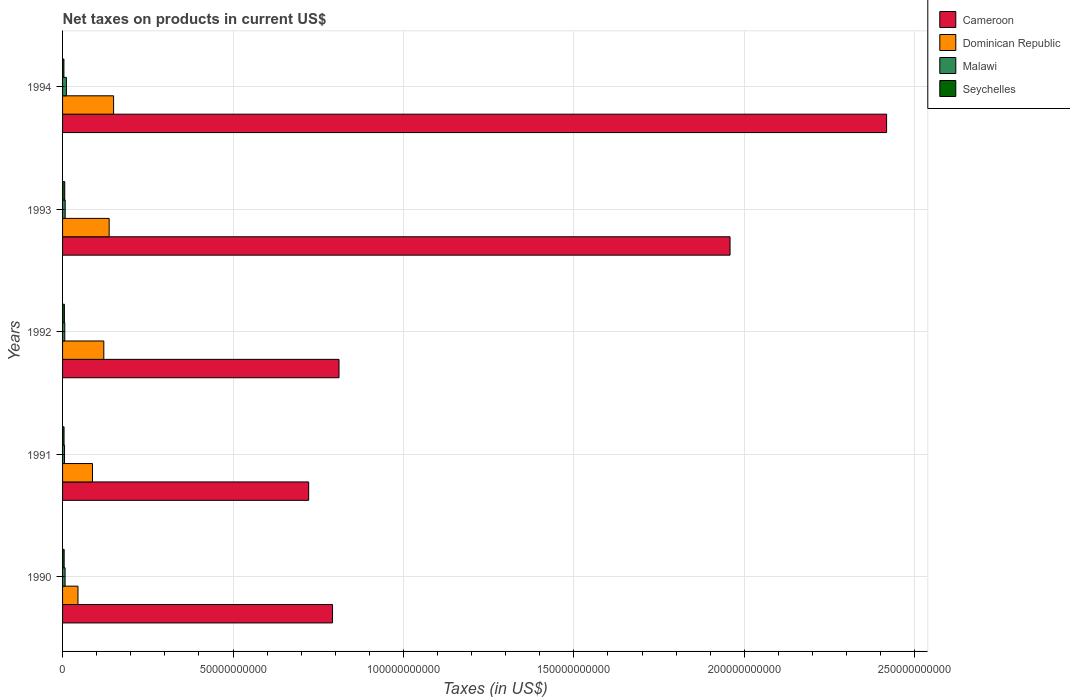How many groups of bars are there?
Offer a very short reply. 5. Are the number of bars per tick equal to the number of legend labels?
Your answer should be very brief. Yes. How many bars are there on the 2nd tick from the top?
Your answer should be compact. 4. How many bars are there on the 1st tick from the bottom?
Make the answer very short. 4. What is the label of the 3rd group of bars from the top?
Offer a very short reply. 1992. What is the net taxes on products in Dominican Republic in 1990?
Provide a short and direct response. 4.52e+09. Across all years, what is the maximum net taxes on products in Malawi?
Provide a succinct answer. 1.13e+09. Across all years, what is the minimum net taxes on products in Seychelles?
Your response must be concise. 3.99e+08. In which year was the net taxes on products in Dominican Republic maximum?
Make the answer very short. 1994. In which year was the net taxes on products in Malawi minimum?
Offer a very short reply. 1991. What is the total net taxes on products in Seychelles in the graph?
Offer a very short reply. 2.48e+09. What is the difference between the net taxes on products in Cameroon in 1990 and that in 1993?
Your answer should be very brief. -1.17e+11. What is the difference between the net taxes on products in Dominican Republic in 1994 and the net taxes on products in Cameroon in 1991?
Your answer should be very brief. -5.72e+1. What is the average net taxes on products in Cameroon per year?
Your answer should be compact. 1.34e+11. In the year 1992, what is the difference between the net taxes on products in Malawi and net taxes on products in Cameroon?
Keep it short and to the point. -8.05e+1. What is the ratio of the net taxes on products in Malawi in 1990 to that in 1992?
Provide a succinct answer. 1.15. Is the net taxes on products in Cameroon in 1990 less than that in 1993?
Keep it short and to the point. Yes. What is the difference between the highest and the second highest net taxes on products in Seychelles?
Provide a succinct answer. 1.05e+08. What is the difference between the highest and the lowest net taxes on products in Malawi?
Provide a short and direct response. 5.51e+08. Is the sum of the net taxes on products in Cameroon in 1990 and 1992 greater than the maximum net taxes on products in Seychelles across all years?
Offer a terse response. Yes. What does the 1st bar from the top in 1994 represents?
Make the answer very short. Seychelles. What does the 2nd bar from the bottom in 1990 represents?
Keep it short and to the point. Dominican Republic. How many bars are there?
Give a very brief answer. 20. Are all the bars in the graph horizontal?
Your answer should be very brief. Yes. How many years are there in the graph?
Provide a succinct answer. 5. How many legend labels are there?
Your answer should be compact. 4. What is the title of the graph?
Keep it short and to the point. Net taxes on products in current US$. Does "Fragile and conflict affected situations" appear as one of the legend labels in the graph?
Provide a short and direct response. No. What is the label or title of the X-axis?
Your response must be concise. Taxes (in US$). What is the label or title of the Y-axis?
Ensure brevity in your answer.  Years. What is the Taxes (in US$) in Cameroon in 1990?
Keep it short and to the point. 7.92e+1. What is the Taxes (in US$) of Dominican Republic in 1990?
Your response must be concise. 4.52e+09. What is the Taxes (in US$) of Malawi in 1990?
Your answer should be very brief. 7.43e+08. What is the Taxes (in US$) in Seychelles in 1990?
Give a very brief answer. 4.66e+08. What is the Taxes (in US$) in Cameroon in 1991?
Make the answer very short. 7.22e+1. What is the Taxes (in US$) in Dominican Republic in 1991?
Offer a terse response. 8.78e+09. What is the Taxes (in US$) in Malawi in 1991?
Provide a short and direct response. 5.76e+08. What is the Taxes (in US$) in Seychelles in 1991?
Provide a short and direct response. 4.37e+08. What is the Taxes (in US$) of Cameroon in 1992?
Make the answer very short. 8.11e+1. What is the Taxes (in US$) in Dominican Republic in 1992?
Provide a short and direct response. 1.21e+1. What is the Taxes (in US$) of Malawi in 1992?
Your answer should be very brief. 6.49e+08. What is the Taxes (in US$) of Seychelles in 1992?
Provide a succinct answer. 5.37e+08. What is the Taxes (in US$) of Cameroon in 1993?
Give a very brief answer. 1.96e+11. What is the Taxes (in US$) in Dominican Republic in 1993?
Ensure brevity in your answer.  1.37e+1. What is the Taxes (in US$) in Malawi in 1993?
Provide a short and direct response. 7.68e+08. What is the Taxes (in US$) of Seychelles in 1993?
Offer a very short reply. 6.43e+08. What is the Taxes (in US$) of Cameroon in 1994?
Ensure brevity in your answer.  2.42e+11. What is the Taxes (in US$) of Dominican Republic in 1994?
Provide a succinct answer. 1.50e+1. What is the Taxes (in US$) of Malawi in 1994?
Your answer should be very brief. 1.13e+09. What is the Taxes (in US$) of Seychelles in 1994?
Your response must be concise. 3.99e+08. Across all years, what is the maximum Taxes (in US$) of Cameroon?
Offer a very short reply. 2.42e+11. Across all years, what is the maximum Taxes (in US$) in Dominican Republic?
Your answer should be very brief. 1.50e+1. Across all years, what is the maximum Taxes (in US$) in Malawi?
Ensure brevity in your answer.  1.13e+09. Across all years, what is the maximum Taxes (in US$) of Seychelles?
Offer a very short reply. 6.43e+08. Across all years, what is the minimum Taxes (in US$) in Cameroon?
Make the answer very short. 7.22e+1. Across all years, what is the minimum Taxes (in US$) in Dominican Republic?
Give a very brief answer. 4.52e+09. Across all years, what is the minimum Taxes (in US$) of Malawi?
Offer a terse response. 5.76e+08. Across all years, what is the minimum Taxes (in US$) of Seychelles?
Ensure brevity in your answer.  3.99e+08. What is the total Taxes (in US$) in Cameroon in the graph?
Give a very brief answer. 6.70e+11. What is the total Taxes (in US$) in Dominican Republic in the graph?
Give a very brief answer. 5.40e+1. What is the total Taxes (in US$) in Malawi in the graph?
Keep it short and to the point. 3.86e+09. What is the total Taxes (in US$) in Seychelles in the graph?
Provide a short and direct response. 2.48e+09. What is the difference between the Taxes (in US$) of Cameroon in 1990 and that in 1991?
Provide a succinct answer. 7.00e+09. What is the difference between the Taxes (in US$) in Dominican Republic in 1990 and that in 1991?
Your answer should be very brief. -4.26e+09. What is the difference between the Taxes (in US$) in Malawi in 1990 and that in 1991?
Keep it short and to the point. 1.68e+08. What is the difference between the Taxes (in US$) in Seychelles in 1990 and that in 1991?
Give a very brief answer. 2.95e+07. What is the difference between the Taxes (in US$) in Cameroon in 1990 and that in 1992?
Your answer should be very brief. -1.90e+09. What is the difference between the Taxes (in US$) of Dominican Republic in 1990 and that in 1992?
Keep it short and to the point. -7.58e+09. What is the difference between the Taxes (in US$) of Malawi in 1990 and that in 1992?
Your response must be concise. 9.45e+07. What is the difference between the Taxes (in US$) in Seychelles in 1990 and that in 1992?
Offer a very short reply. -7.12e+07. What is the difference between the Taxes (in US$) in Cameroon in 1990 and that in 1993?
Give a very brief answer. -1.17e+11. What is the difference between the Taxes (in US$) in Dominican Republic in 1990 and that in 1993?
Provide a short and direct response. -9.15e+09. What is the difference between the Taxes (in US$) of Malawi in 1990 and that in 1993?
Make the answer very short. -2.50e+07. What is the difference between the Taxes (in US$) in Seychelles in 1990 and that in 1993?
Provide a short and direct response. -1.76e+08. What is the difference between the Taxes (in US$) in Cameroon in 1990 and that in 1994?
Offer a very short reply. -1.63e+11. What is the difference between the Taxes (in US$) of Dominican Republic in 1990 and that in 1994?
Ensure brevity in your answer.  -1.04e+1. What is the difference between the Taxes (in US$) of Malawi in 1990 and that in 1994?
Provide a succinct answer. -3.83e+08. What is the difference between the Taxes (in US$) of Seychelles in 1990 and that in 1994?
Keep it short and to the point. 6.71e+07. What is the difference between the Taxes (in US$) in Cameroon in 1991 and that in 1992?
Ensure brevity in your answer.  -8.90e+09. What is the difference between the Taxes (in US$) in Dominican Republic in 1991 and that in 1992?
Provide a short and direct response. -3.32e+09. What is the difference between the Taxes (in US$) in Malawi in 1991 and that in 1992?
Provide a succinct answer. -7.32e+07. What is the difference between the Taxes (in US$) of Seychelles in 1991 and that in 1992?
Your answer should be very brief. -1.01e+08. What is the difference between the Taxes (in US$) of Cameroon in 1991 and that in 1993?
Give a very brief answer. -1.24e+11. What is the difference between the Taxes (in US$) of Dominican Republic in 1991 and that in 1993?
Provide a short and direct response. -4.89e+09. What is the difference between the Taxes (in US$) of Malawi in 1991 and that in 1993?
Your answer should be very brief. -1.93e+08. What is the difference between the Taxes (in US$) in Seychelles in 1991 and that in 1993?
Provide a succinct answer. -2.06e+08. What is the difference between the Taxes (in US$) in Cameroon in 1991 and that in 1994?
Ensure brevity in your answer.  -1.70e+11. What is the difference between the Taxes (in US$) of Dominican Republic in 1991 and that in 1994?
Provide a short and direct response. -6.19e+09. What is the difference between the Taxes (in US$) in Malawi in 1991 and that in 1994?
Your response must be concise. -5.51e+08. What is the difference between the Taxes (in US$) in Seychelles in 1991 and that in 1994?
Ensure brevity in your answer.  3.76e+07. What is the difference between the Taxes (in US$) of Cameroon in 1992 and that in 1993?
Provide a succinct answer. -1.15e+11. What is the difference between the Taxes (in US$) in Dominican Republic in 1992 and that in 1993?
Keep it short and to the point. -1.57e+09. What is the difference between the Taxes (in US$) in Malawi in 1992 and that in 1993?
Provide a short and direct response. -1.20e+08. What is the difference between the Taxes (in US$) of Seychelles in 1992 and that in 1993?
Your answer should be very brief. -1.05e+08. What is the difference between the Taxes (in US$) of Cameroon in 1992 and that in 1994?
Keep it short and to the point. -1.61e+11. What is the difference between the Taxes (in US$) in Dominican Republic in 1992 and that in 1994?
Offer a terse response. -2.87e+09. What is the difference between the Taxes (in US$) in Malawi in 1992 and that in 1994?
Offer a terse response. -4.77e+08. What is the difference between the Taxes (in US$) of Seychelles in 1992 and that in 1994?
Make the answer very short. 1.38e+08. What is the difference between the Taxes (in US$) of Cameroon in 1993 and that in 1994?
Your response must be concise. -4.59e+1. What is the difference between the Taxes (in US$) of Dominican Republic in 1993 and that in 1994?
Ensure brevity in your answer.  -1.30e+09. What is the difference between the Taxes (in US$) in Malawi in 1993 and that in 1994?
Make the answer very short. -3.58e+08. What is the difference between the Taxes (in US$) of Seychelles in 1993 and that in 1994?
Make the answer very short. 2.44e+08. What is the difference between the Taxes (in US$) of Cameroon in 1990 and the Taxes (in US$) of Dominican Republic in 1991?
Provide a succinct answer. 7.04e+1. What is the difference between the Taxes (in US$) in Cameroon in 1990 and the Taxes (in US$) in Malawi in 1991?
Give a very brief answer. 7.86e+1. What is the difference between the Taxes (in US$) in Cameroon in 1990 and the Taxes (in US$) in Seychelles in 1991?
Provide a short and direct response. 7.88e+1. What is the difference between the Taxes (in US$) in Dominican Republic in 1990 and the Taxes (in US$) in Malawi in 1991?
Ensure brevity in your answer.  3.95e+09. What is the difference between the Taxes (in US$) of Dominican Republic in 1990 and the Taxes (in US$) of Seychelles in 1991?
Offer a very short reply. 4.09e+09. What is the difference between the Taxes (in US$) of Malawi in 1990 and the Taxes (in US$) of Seychelles in 1991?
Your answer should be very brief. 3.07e+08. What is the difference between the Taxes (in US$) in Cameroon in 1990 and the Taxes (in US$) in Dominican Republic in 1992?
Provide a succinct answer. 6.71e+1. What is the difference between the Taxes (in US$) of Cameroon in 1990 and the Taxes (in US$) of Malawi in 1992?
Make the answer very short. 7.86e+1. What is the difference between the Taxes (in US$) of Cameroon in 1990 and the Taxes (in US$) of Seychelles in 1992?
Keep it short and to the point. 7.87e+1. What is the difference between the Taxes (in US$) of Dominican Republic in 1990 and the Taxes (in US$) of Malawi in 1992?
Your answer should be compact. 3.87e+09. What is the difference between the Taxes (in US$) in Dominican Republic in 1990 and the Taxes (in US$) in Seychelles in 1992?
Offer a terse response. 3.99e+09. What is the difference between the Taxes (in US$) in Malawi in 1990 and the Taxes (in US$) in Seychelles in 1992?
Your answer should be very brief. 2.06e+08. What is the difference between the Taxes (in US$) of Cameroon in 1990 and the Taxes (in US$) of Dominican Republic in 1993?
Your answer should be very brief. 6.55e+1. What is the difference between the Taxes (in US$) in Cameroon in 1990 and the Taxes (in US$) in Malawi in 1993?
Your response must be concise. 7.84e+1. What is the difference between the Taxes (in US$) of Cameroon in 1990 and the Taxes (in US$) of Seychelles in 1993?
Provide a succinct answer. 7.86e+1. What is the difference between the Taxes (in US$) of Dominican Republic in 1990 and the Taxes (in US$) of Malawi in 1993?
Your response must be concise. 3.75e+09. What is the difference between the Taxes (in US$) of Dominican Republic in 1990 and the Taxes (in US$) of Seychelles in 1993?
Your answer should be very brief. 3.88e+09. What is the difference between the Taxes (in US$) in Malawi in 1990 and the Taxes (in US$) in Seychelles in 1993?
Provide a succinct answer. 1.01e+08. What is the difference between the Taxes (in US$) in Cameroon in 1990 and the Taxes (in US$) in Dominican Republic in 1994?
Make the answer very short. 6.42e+1. What is the difference between the Taxes (in US$) of Cameroon in 1990 and the Taxes (in US$) of Malawi in 1994?
Your answer should be compact. 7.81e+1. What is the difference between the Taxes (in US$) of Cameroon in 1990 and the Taxes (in US$) of Seychelles in 1994?
Provide a succinct answer. 7.88e+1. What is the difference between the Taxes (in US$) in Dominican Republic in 1990 and the Taxes (in US$) in Malawi in 1994?
Keep it short and to the point. 3.40e+09. What is the difference between the Taxes (in US$) of Dominican Republic in 1990 and the Taxes (in US$) of Seychelles in 1994?
Offer a very short reply. 4.12e+09. What is the difference between the Taxes (in US$) in Malawi in 1990 and the Taxes (in US$) in Seychelles in 1994?
Your response must be concise. 3.44e+08. What is the difference between the Taxes (in US$) of Cameroon in 1991 and the Taxes (in US$) of Dominican Republic in 1992?
Your answer should be compact. 6.01e+1. What is the difference between the Taxes (in US$) of Cameroon in 1991 and the Taxes (in US$) of Malawi in 1992?
Provide a succinct answer. 7.16e+1. What is the difference between the Taxes (in US$) of Cameroon in 1991 and the Taxes (in US$) of Seychelles in 1992?
Offer a terse response. 7.17e+1. What is the difference between the Taxes (in US$) in Dominican Republic in 1991 and the Taxes (in US$) in Malawi in 1992?
Make the answer very short. 8.13e+09. What is the difference between the Taxes (in US$) in Dominican Republic in 1991 and the Taxes (in US$) in Seychelles in 1992?
Keep it short and to the point. 8.24e+09. What is the difference between the Taxes (in US$) in Malawi in 1991 and the Taxes (in US$) in Seychelles in 1992?
Your answer should be very brief. 3.82e+07. What is the difference between the Taxes (in US$) in Cameroon in 1991 and the Taxes (in US$) in Dominican Republic in 1993?
Make the answer very short. 5.85e+1. What is the difference between the Taxes (in US$) of Cameroon in 1991 and the Taxes (in US$) of Malawi in 1993?
Your response must be concise. 7.14e+1. What is the difference between the Taxes (in US$) of Cameroon in 1991 and the Taxes (in US$) of Seychelles in 1993?
Make the answer very short. 7.16e+1. What is the difference between the Taxes (in US$) in Dominican Republic in 1991 and the Taxes (in US$) in Malawi in 1993?
Your answer should be very brief. 8.01e+09. What is the difference between the Taxes (in US$) in Dominican Republic in 1991 and the Taxes (in US$) in Seychelles in 1993?
Provide a succinct answer. 8.14e+09. What is the difference between the Taxes (in US$) of Malawi in 1991 and the Taxes (in US$) of Seychelles in 1993?
Give a very brief answer. -6.71e+07. What is the difference between the Taxes (in US$) of Cameroon in 1991 and the Taxes (in US$) of Dominican Republic in 1994?
Your answer should be very brief. 5.72e+1. What is the difference between the Taxes (in US$) in Cameroon in 1991 and the Taxes (in US$) in Malawi in 1994?
Your answer should be very brief. 7.11e+1. What is the difference between the Taxes (in US$) in Cameroon in 1991 and the Taxes (in US$) in Seychelles in 1994?
Your answer should be very brief. 7.18e+1. What is the difference between the Taxes (in US$) of Dominican Republic in 1991 and the Taxes (in US$) of Malawi in 1994?
Provide a short and direct response. 7.66e+09. What is the difference between the Taxes (in US$) of Dominican Republic in 1991 and the Taxes (in US$) of Seychelles in 1994?
Make the answer very short. 8.38e+09. What is the difference between the Taxes (in US$) of Malawi in 1991 and the Taxes (in US$) of Seychelles in 1994?
Give a very brief answer. 1.76e+08. What is the difference between the Taxes (in US$) of Cameroon in 1992 and the Taxes (in US$) of Dominican Republic in 1993?
Provide a succinct answer. 6.74e+1. What is the difference between the Taxes (in US$) of Cameroon in 1992 and the Taxes (in US$) of Malawi in 1993?
Keep it short and to the point. 8.03e+1. What is the difference between the Taxes (in US$) in Cameroon in 1992 and the Taxes (in US$) in Seychelles in 1993?
Your answer should be very brief. 8.05e+1. What is the difference between the Taxes (in US$) in Dominican Republic in 1992 and the Taxes (in US$) in Malawi in 1993?
Your answer should be compact. 1.13e+1. What is the difference between the Taxes (in US$) in Dominican Republic in 1992 and the Taxes (in US$) in Seychelles in 1993?
Your answer should be very brief. 1.15e+1. What is the difference between the Taxes (in US$) in Malawi in 1992 and the Taxes (in US$) in Seychelles in 1993?
Your answer should be compact. 6.10e+06. What is the difference between the Taxes (in US$) of Cameroon in 1992 and the Taxes (in US$) of Dominican Republic in 1994?
Ensure brevity in your answer.  6.61e+1. What is the difference between the Taxes (in US$) in Cameroon in 1992 and the Taxes (in US$) in Malawi in 1994?
Offer a terse response. 8.00e+1. What is the difference between the Taxes (in US$) in Cameroon in 1992 and the Taxes (in US$) in Seychelles in 1994?
Your answer should be compact. 8.07e+1. What is the difference between the Taxes (in US$) in Dominican Republic in 1992 and the Taxes (in US$) in Malawi in 1994?
Offer a very short reply. 1.10e+1. What is the difference between the Taxes (in US$) in Dominican Republic in 1992 and the Taxes (in US$) in Seychelles in 1994?
Your answer should be compact. 1.17e+1. What is the difference between the Taxes (in US$) in Malawi in 1992 and the Taxes (in US$) in Seychelles in 1994?
Your response must be concise. 2.50e+08. What is the difference between the Taxes (in US$) of Cameroon in 1993 and the Taxes (in US$) of Dominican Republic in 1994?
Ensure brevity in your answer.  1.81e+11. What is the difference between the Taxes (in US$) of Cameroon in 1993 and the Taxes (in US$) of Malawi in 1994?
Offer a very short reply. 1.95e+11. What is the difference between the Taxes (in US$) of Cameroon in 1993 and the Taxes (in US$) of Seychelles in 1994?
Make the answer very short. 1.95e+11. What is the difference between the Taxes (in US$) of Dominican Republic in 1993 and the Taxes (in US$) of Malawi in 1994?
Your response must be concise. 1.25e+1. What is the difference between the Taxes (in US$) in Dominican Republic in 1993 and the Taxes (in US$) in Seychelles in 1994?
Provide a succinct answer. 1.33e+1. What is the difference between the Taxes (in US$) of Malawi in 1993 and the Taxes (in US$) of Seychelles in 1994?
Give a very brief answer. 3.69e+08. What is the average Taxes (in US$) in Cameroon per year?
Make the answer very short. 1.34e+11. What is the average Taxes (in US$) of Dominican Republic per year?
Offer a terse response. 1.08e+1. What is the average Taxes (in US$) in Malawi per year?
Your response must be concise. 7.72e+08. What is the average Taxes (in US$) in Seychelles per year?
Make the answer very short. 4.96e+08. In the year 1990, what is the difference between the Taxes (in US$) in Cameroon and Taxes (in US$) in Dominican Republic?
Make the answer very short. 7.47e+1. In the year 1990, what is the difference between the Taxes (in US$) of Cameroon and Taxes (in US$) of Malawi?
Provide a succinct answer. 7.85e+1. In the year 1990, what is the difference between the Taxes (in US$) in Cameroon and Taxes (in US$) in Seychelles?
Keep it short and to the point. 7.87e+1. In the year 1990, what is the difference between the Taxes (in US$) of Dominican Republic and Taxes (in US$) of Malawi?
Provide a succinct answer. 3.78e+09. In the year 1990, what is the difference between the Taxes (in US$) of Dominican Republic and Taxes (in US$) of Seychelles?
Offer a terse response. 4.06e+09. In the year 1990, what is the difference between the Taxes (in US$) of Malawi and Taxes (in US$) of Seychelles?
Your response must be concise. 2.77e+08. In the year 1991, what is the difference between the Taxes (in US$) of Cameroon and Taxes (in US$) of Dominican Republic?
Your answer should be very brief. 6.34e+1. In the year 1991, what is the difference between the Taxes (in US$) of Cameroon and Taxes (in US$) of Malawi?
Make the answer very short. 7.16e+1. In the year 1991, what is the difference between the Taxes (in US$) in Cameroon and Taxes (in US$) in Seychelles?
Ensure brevity in your answer.  7.18e+1. In the year 1991, what is the difference between the Taxes (in US$) in Dominican Republic and Taxes (in US$) in Malawi?
Ensure brevity in your answer.  8.21e+09. In the year 1991, what is the difference between the Taxes (in US$) in Dominican Republic and Taxes (in US$) in Seychelles?
Offer a very short reply. 8.35e+09. In the year 1991, what is the difference between the Taxes (in US$) of Malawi and Taxes (in US$) of Seychelles?
Your answer should be very brief. 1.39e+08. In the year 1992, what is the difference between the Taxes (in US$) in Cameroon and Taxes (in US$) in Dominican Republic?
Make the answer very short. 6.90e+1. In the year 1992, what is the difference between the Taxes (in US$) of Cameroon and Taxes (in US$) of Malawi?
Your response must be concise. 8.05e+1. In the year 1992, what is the difference between the Taxes (in US$) of Cameroon and Taxes (in US$) of Seychelles?
Your answer should be very brief. 8.06e+1. In the year 1992, what is the difference between the Taxes (in US$) in Dominican Republic and Taxes (in US$) in Malawi?
Ensure brevity in your answer.  1.15e+1. In the year 1992, what is the difference between the Taxes (in US$) in Dominican Republic and Taxes (in US$) in Seychelles?
Offer a terse response. 1.16e+1. In the year 1992, what is the difference between the Taxes (in US$) of Malawi and Taxes (in US$) of Seychelles?
Provide a succinct answer. 1.11e+08. In the year 1993, what is the difference between the Taxes (in US$) in Cameroon and Taxes (in US$) in Dominican Republic?
Keep it short and to the point. 1.82e+11. In the year 1993, what is the difference between the Taxes (in US$) in Cameroon and Taxes (in US$) in Malawi?
Ensure brevity in your answer.  1.95e+11. In the year 1993, what is the difference between the Taxes (in US$) of Cameroon and Taxes (in US$) of Seychelles?
Your answer should be very brief. 1.95e+11. In the year 1993, what is the difference between the Taxes (in US$) in Dominican Republic and Taxes (in US$) in Malawi?
Your answer should be compact. 1.29e+1. In the year 1993, what is the difference between the Taxes (in US$) of Dominican Republic and Taxes (in US$) of Seychelles?
Keep it short and to the point. 1.30e+1. In the year 1993, what is the difference between the Taxes (in US$) of Malawi and Taxes (in US$) of Seychelles?
Offer a terse response. 1.26e+08. In the year 1994, what is the difference between the Taxes (in US$) in Cameroon and Taxes (in US$) in Dominican Republic?
Your response must be concise. 2.27e+11. In the year 1994, what is the difference between the Taxes (in US$) of Cameroon and Taxes (in US$) of Malawi?
Your response must be concise. 2.41e+11. In the year 1994, what is the difference between the Taxes (in US$) of Cameroon and Taxes (in US$) of Seychelles?
Your response must be concise. 2.41e+11. In the year 1994, what is the difference between the Taxes (in US$) of Dominican Republic and Taxes (in US$) of Malawi?
Provide a short and direct response. 1.38e+1. In the year 1994, what is the difference between the Taxes (in US$) in Dominican Republic and Taxes (in US$) in Seychelles?
Offer a terse response. 1.46e+1. In the year 1994, what is the difference between the Taxes (in US$) in Malawi and Taxes (in US$) in Seychelles?
Offer a very short reply. 7.27e+08. What is the ratio of the Taxes (in US$) in Cameroon in 1990 to that in 1991?
Provide a succinct answer. 1.1. What is the ratio of the Taxes (in US$) of Dominican Republic in 1990 to that in 1991?
Your answer should be compact. 0.52. What is the ratio of the Taxes (in US$) in Malawi in 1990 to that in 1991?
Your answer should be compact. 1.29. What is the ratio of the Taxes (in US$) of Seychelles in 1990 to that in 1991?
Give a very brief answer. 1.07. What is the ratio of the Taxes (in US$) in Cameroon in 1990 to that in 1992?
Ensure brevity in your answer.  0.98. What is the ratio of the Taxes (in US$) in Dominican Republic in 1990 to that in 1992?
Ensure brevity in your answer.  0.37. What is the ratio of the Taxes (in US$) of Malawi in 1990 to that in 1992?
Provide a short and direct response. 1.15. What is the ratio of the Taxes (in US$) in Seychelles in 1990 to that in 1992?
Offer a terse response. 0.87. What is the ratio of the Taxes (in US$) of Cameroon in 1990 to that in 1993?
Your answer should be very brief. 0.4. What is the ratio of the Taxes (in US$) of Dominican Republic in 1990 to that in 1993?
Make the answer very short. 0.33. What is the ratio of the Taxes (in US$) in Malawi in 1990 to that in 1993?
Your answer should be very brief. 0.97. What is the ratio of the Taxes (in US$) in Seychelles in 1990 to that in 1993?
Keep it short and to the point. 0.73. What is the ratio of the Taxes (in US$) in Cameroon in 1990 to that in 1994?
Your answer should be very brief. 0.33. What is the ratio of the Taxes (in US$) in Dominican Republic in 1990 to that in 1994?
Your response must be concise. 0.3. What is the ratio of the Taxes (in US$) of Malawi in 1990 to that in 1994?
Keep it short and to the point. 0.66. What is the ratio of the Taxes (in US$) in Seychelles in 1990 to that in 1994?
Give a very brief answer. 1.17. What is the ratio of the Taxes (in US$) in Cameroon in 1991 to that in 1992?
Give a very brief answer. 0.89. What is the ratio of the Taxes (in US$) of Dominican Republic in 1991 to that in 1992?
Provide a succinct answer. 0.73. What is the ratio of the Taxes (in US$) in Malawi in 1991 to that in 1992?
Provide a succinct answer. 0.89. What is the ratio of the Taxes (in US$) in Seychelles in 1991 to that in 1992?
Make the answer very short. 0.81. What is the ratio of the Taxes (in US$) of Cameroon in 1991 to that in 1993?
Give a very brief answer. 0.37. What is the ratio of the Taxes (in US$) in Dominican Republic in 1991 to that in 1993?
Keep it short and to the point. 0.64. What is the ratio of the Taxes (in US$) of Malawi in 1991 to that in 1993?
Provide a succinct answer. 0.75. What is the ratio of the Taxes (in US$) in Seychelles in 1991 to that in 1993?
Keep it short and to the point. 0.68. What is the ratio of the Taxes (in US$) in Cameroon in 1991 to that in 1994?
Make the answer very short. 0.3. What is the ratio of the Taxes (in US$) of Dominican Republic in 1991 to that in 1994?
Your answer should be very brief. 0.59. What is the ratio of the Taxes (in US$) of Malawi in 1991 to that in 1994?
Your answer should be compact. 0.51. What is the ratio of the Taxes (in US$) of Seychelles in 1991 to that in 1994?
Provide a succinct answer. 1.09. What is the ratio of the Taxes (in US$) of Cameroon in 1992 to that in 1993?
Provide a short and direct response. 0.41. What is the ratio of the Taxes (in US$) in Dominican Republic in 1992 to that in 1993?
Offer a terse response. 0.89. What is the ratio of the Taxes (in US$) of Malawi in 1992 to that in 1993?
Provide a succinct answer. 0.84. What is the ratio of the Taxes (in US$) in Seychelles in 1992 to that in 1993?
Offer a terse response. 0.84. What is the ratio of the Taxes (in US$) of Cameroon in 1992 to that in 1994?
Offer a terse response. 0.34. What is the ratio of the Taxes (in US$) in Dominican Republic in 1992 to that in 1994?
Your answer should be compact. 0.81. What is the ratio of the Taxes (in US$) in Malawi in 1992 to that in 1994?
Ensure brevity in your answer.  0.58. What is the ratio of the Taxes (in US$) of Seychelles in 1992 to that in 1994?
Provide a succinct answer. 1.35. What is the ratio of the Taxes (in US$) of Cameroon in 1993 to that in 1994?
Offer a terse response. 0.81. What is the ratio of the Taxes (in US$) in Dominican Republic in 1993 to that in 1994?
Keep it short and to the point. 0.91. What is the ratio of the Taxes (in US$) of Malawi in 1993 to that in 1994?
Offer a very short reply. 0.68. What is the ratio of the Taxes (in US$) of Seychelles in 1993 to that in 1994?
Offer a terse response. 1.61. What is the difference between the highest and the second highest Taxes (in US$) in Cameroon?
Your response must be concise. 4.59e+1. What is the difference between the highest and the second highest Taxes (in US$) in Dominican Republic?
Offer a terse response. 1.30e+09. What is the difference between the highest and the second highest Taxes (in US$) in Malawi?
Your answer should be compact. 3.58e+08. What is the difference between the highest and the second highest Taxes (in US$) in Seychelles?
Provide a short and direct response. 1.05e+08. What is the difference between the highest and the lowest Taxes (in US$) of Cameroon?
Your answer should be very brief. 1.70e+11. What is the difference between the highest and the lowest Taxes (in US$) in Dominican Republic?
Give a very brief answer. 1.04e+1. What is the difference between the highest and the lowest Taxes (in US$) in Malawi?
Offer a very short reply. 5.51e+08. What is the difference between the highest and the lowest Taxes (in US$) of Seychelles?
Ensure brevity in your answer.  2.44e+08. 